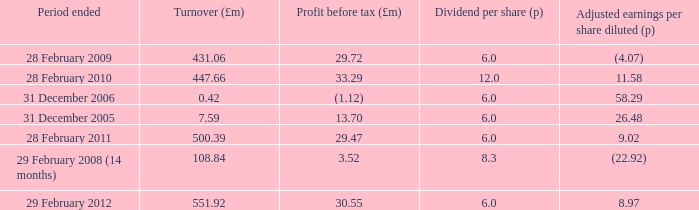How many items appear in the dividend per share when the turnover is 0.42? 1.0. 